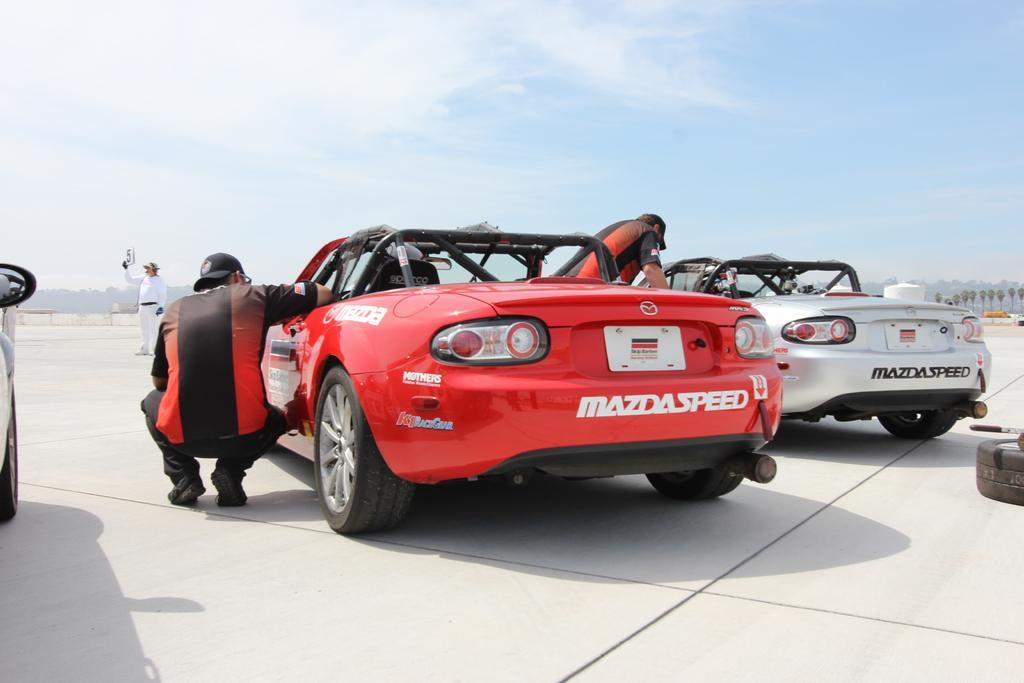Could you give a brief overview of what you see in this image? In this image we can see group of cars parked on the road. Two persons are wearing uniforms are standing beside the cars. One person wearing white dress is holding a card in his hand. In the background ,we can see group of trees ,mountains and sky. 